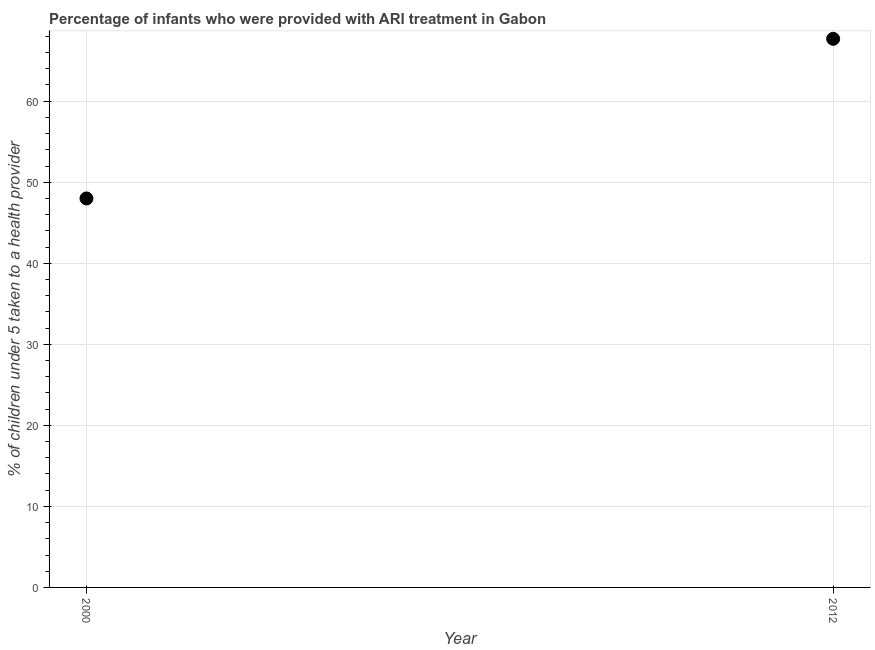What is the percentage of children who were provided with ari treatment in 2012?
Ensure brevity in your answer.  67.7. Across all years, what is the maximum percentage of children who were provided with ari treatment?
Offer a terse response. 67.7. In which year was the percentage of children who were provided with ari treatment maximum?
Your response must be concise. 2012. In which year was the percentage of children who were provided with ari treatment minimum?
Offer a terse response. 2000. What is the sum of the percentage of children who were provided with ari treatment?
Offer a terse response. 115.7. What is the difference between the percentage of children who were provided with ari treatment in 2000 and 2012?
Offer a very short reply. -19.7. What is the average percentage of children who were provided with ari treatment per year?
Offer a very short reply. 57.85. What is the median percentage of children who were provided with ari treatment?
Provide a succinct answer. 57.85. In how many years, is the percentage of children who were provided with ari treatment greater than 30 %?
Your answer should be compact. 2. What is the ratio of the percentage of children who were provided with ari treatment in 2000 to that in 2012?
Provide a short and direct response. 0.71. In how many years, is the percentage of children who were provided with ari treatment greater than the average percentage of children who were provided with ari treatment taken over all years?
Your answer should be very brief. 1. Does the percentage of children who were provided with ari treatment monotonically increase over the years?
Your response must be concise. Yes. How many dotlines are there?
Provide a succinct answer. 1. What is the difference between two consecutive major ticks on the Y-axis?
Your answer should be very brief. 10. What is the title of the graph?
Provide a short and direct response. Percentage of infants who were provided with ARI treatment in Gabon. What is the label or title of the Y-axis?
Keep it short and to the point. % of children under 5 taken to a health provider. What is the % of children under 5 taken to a health provider in 2012?
Offer a very short reply. 67.7. What is the difference between the % of children under 5 taken to a health provider in 2000 and 2012?
Your response must be concise. -19.7. What is the ratio of the % of children under 5 taken to a health provider in 2000 to that in 2012?
Give a very brief answer. 0.71. 